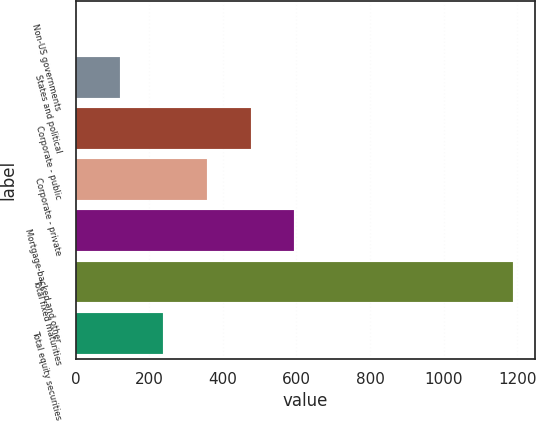<chart> <loc_0><loc_0><loc_500><loc_500><bar_chart><fcel>Non-US governments<fcel>States and political<fcel>Corporate - public<fcel>Corporate - private<fcel>Mortgage-backed and other<fcel>Total fixed maturities<fcel>Total equity securities<nl><fcel>1.3<fcel>119.93<fcel>475.82<fcel>357.19<fcel>594.45<fcel>1187.6<fcel>238.56<nl></chart> 